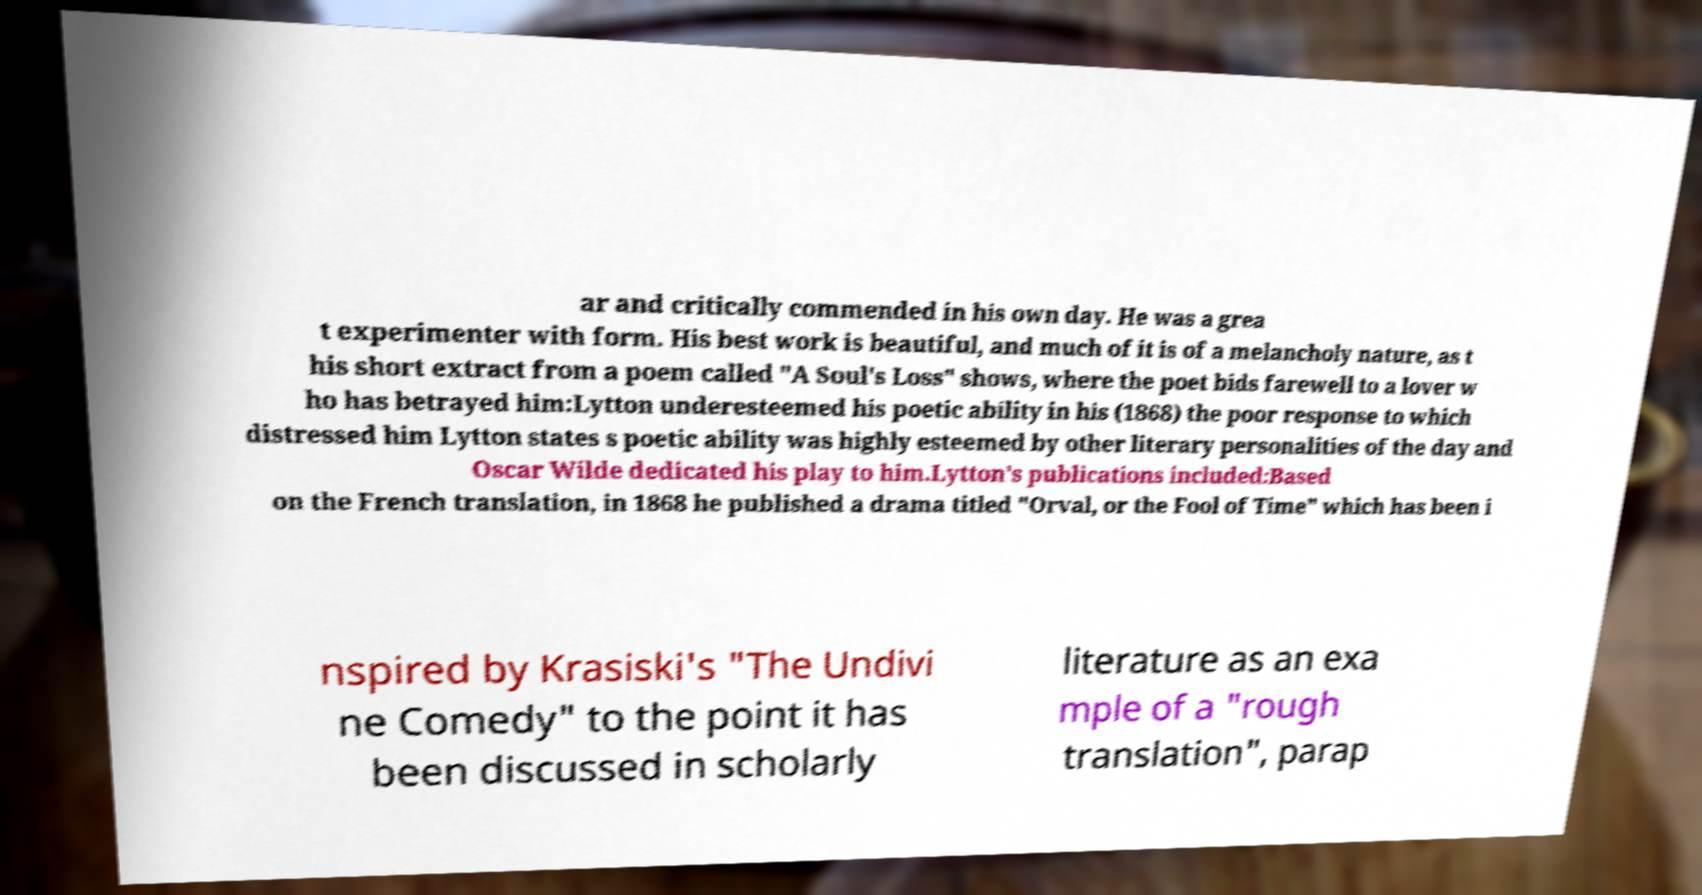Please read and relay the text visible in this image. What does it say? ar and critically commended in his own day. He was a grea t experimenter with form. His best work is beautiful, and much of it is of a melancholy nature, as t his short extract from a poem called "A Soul's Loss" shows, where the poet bids farewell to a lover w ho has betrayed him:Lytton underesteemed his poetic ability in his (1868) the poor response to which distressed him Lytton states s poetic ability was highly esteemed by other literary personalities of the day and Oscar Wilde dedicated his play to him.Lytton's publications included:Based on the French translation, in 1868 he published a drama titled "Orval, or the Fool of Time" which has been i nspired by Krasiski's "The Undivi ne Comedy" to the point it has been discussed in scholarly literature as an exa mple of a "rough translation", parap 